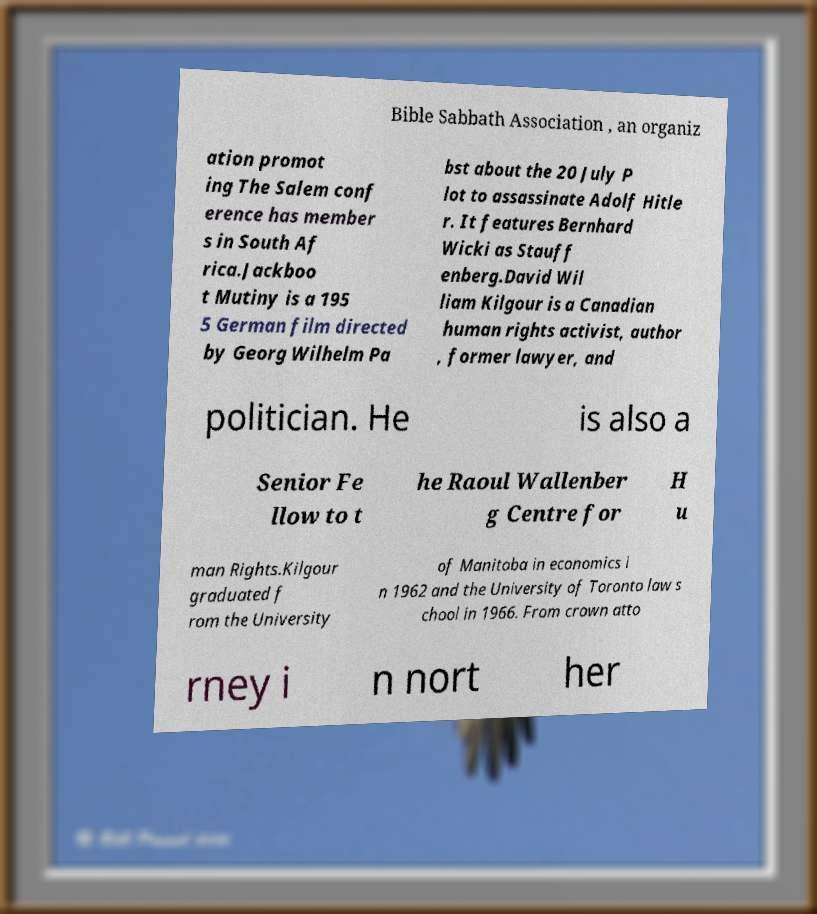I need the written content from this picture converted into text. Can you do that? Bible Sabbath Association , an organiz ation promot ing The Salem conf erence has member s in South Af rica.Jackboo t Mutiny is a 195 5 German film directed by Georg Wilhelm Pa bst about the 20 July P lot to assassinate Adolf Hitle r. It features Bernhard Wicki as Stauff enberg.David Wil liam Kilgour is a Canadian human rights activist, author , former lawyer, and politician. He is also a Senior Fe llow to t he Raoul Wallenber g Centre for H u man Rights.Kilgour graduated f rom the University of Manitoba in economics i n 1962 and the University of Toronto law s chool in 1966. From crown atto rney i n nort her 